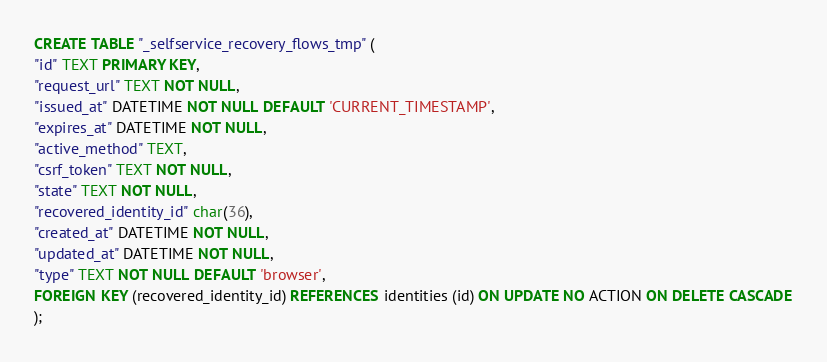<code> <loc_0><loc_0><loc_500><loc_500><_SQL_>CREATE TABLE "_selfservice_recovery_flows_tmp" (
"id" TEXT PRIMARY KEY,
"request_url" TEXT NOT NULL,
"issued_at" DATETIME NOT NULL DEFAULT 'CURRENT_TIMESTAMP',
"expires_at" DATETIME NOT NULL,
"active_method" TEXT,
"csrf_token" TEXT NOT NULL,
"state" TEXT NOT NULL,
"recovered_identity_id" char(36),
"created_at" DATETIME NOT NULL,
"updated_at" DATETIME NOT NULL,
"type" TEXT NOT NULL DEFAULT 'browser',
FOREIGN KEY (recovered_identity_id) REFERENCES identities (id) ON UPDATE NO ACTION ON DELETE CASCADE
);</code> 